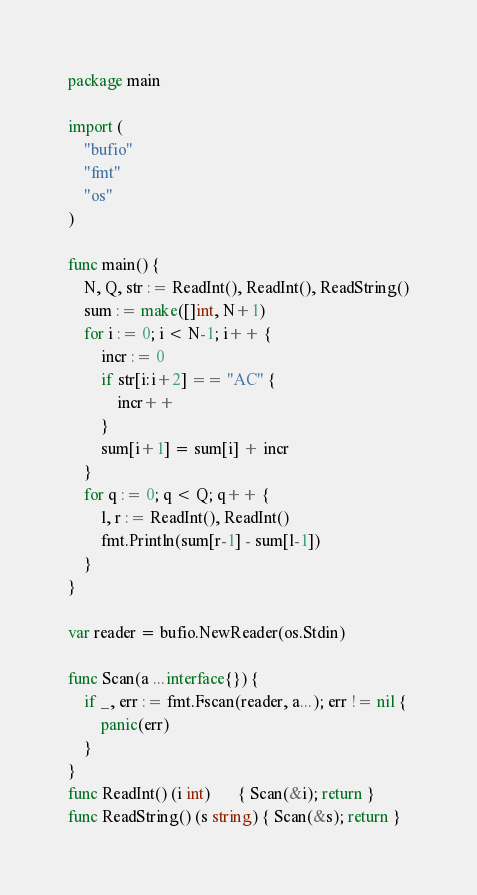<code> <loc_0><loc_0><loc_500><loc_500><_Go_>package main

import (
	"bufio"
	"fmt"
	"os"
)

func main() {
	N, Q, str := ReadInt(), ReadInt(), ReadString()
	sum := make([]int, N+1)
	for i := 0; i < N-1; i++ {
		incr := 0
		if str[i:i+2] == "AC" {
			incr++
		}
		sum[i+1] = sum[i] + incr
	}
	for q := 0; q < Q; q++ {
		l, r := ReadInt(), ReadInt()
		fmt.Println(sum[r-1] - sum[l-1])
	}
}

var reader = bufio.NewReader(os.Stdin)

func Scan(a ...interface{}) {
	if _, err := fmt.Fscan(reader, a...); err != nil {
		panic(err)
	}
}
func ReadInt() (i int)       { Scan(&i); return }
func ReadString() (s string) { Scan(&s); return }
</code> 